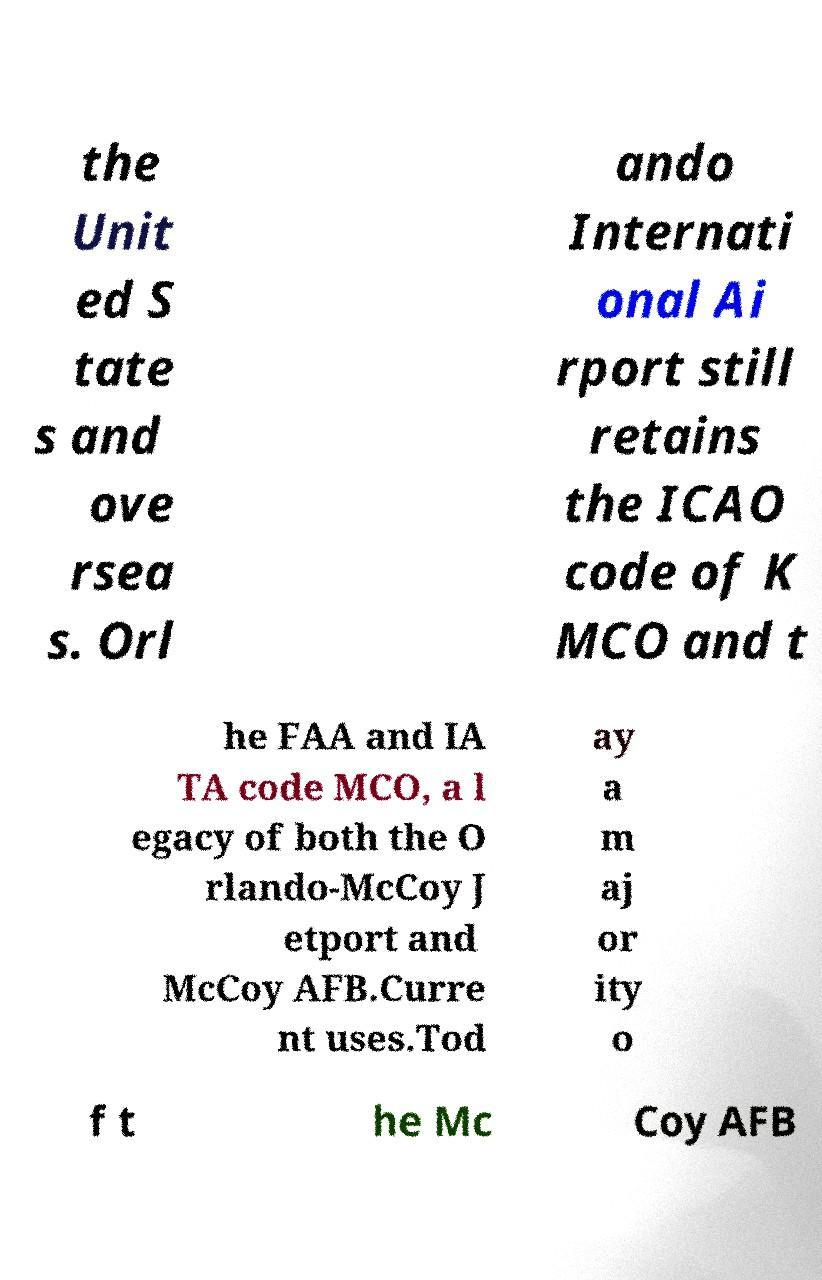Could you assist in decoding the text presented in this image and type it out clearly? the Unit ed S tate s and ove rsea s. Orl ando Internati onal Ai rport still retains the ICAO code of K MCO and t he FAA and IA TA code MCO, a l egacy of both the O rlando-McCoy J etport and McCoy AFB.Curre nt uses.Tod ay a m aj or ity o f t he Mc Coy AFB 